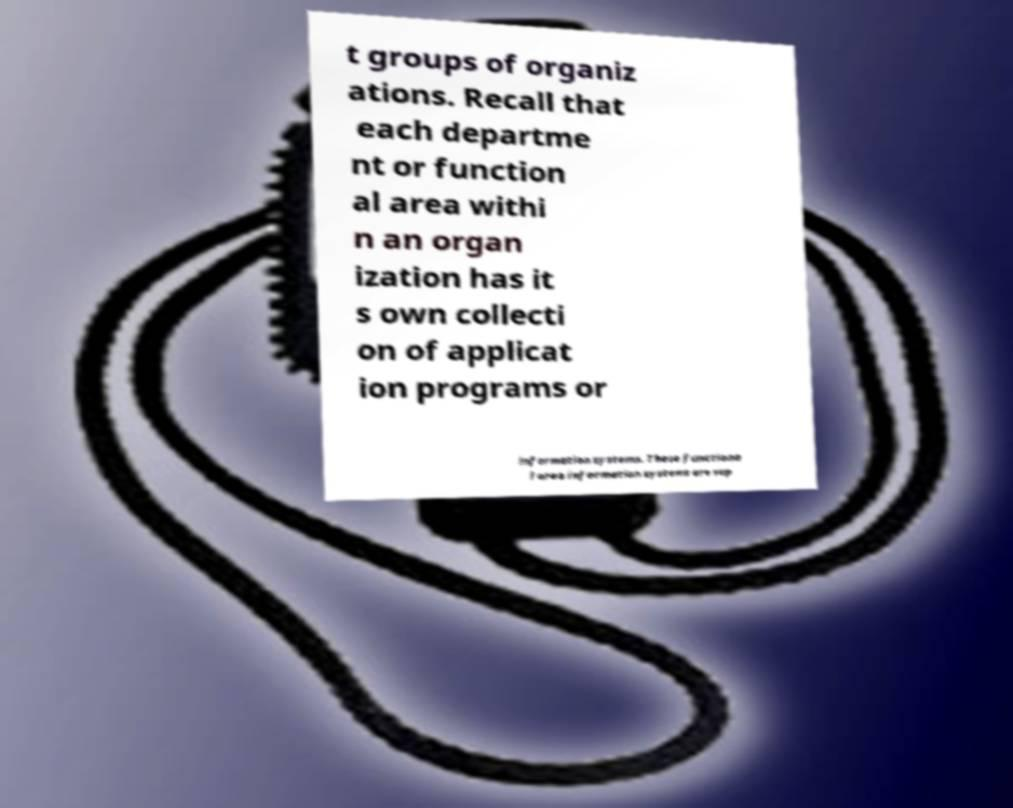What messages or text are displayed in this image? I need them in a readable, typed format. t groups of organiz ations. Recall that each departme nt or function al area withi n an organ ization has it s own collecti on of applicat ion programs or information systems. These functiona l area information systems are sup 